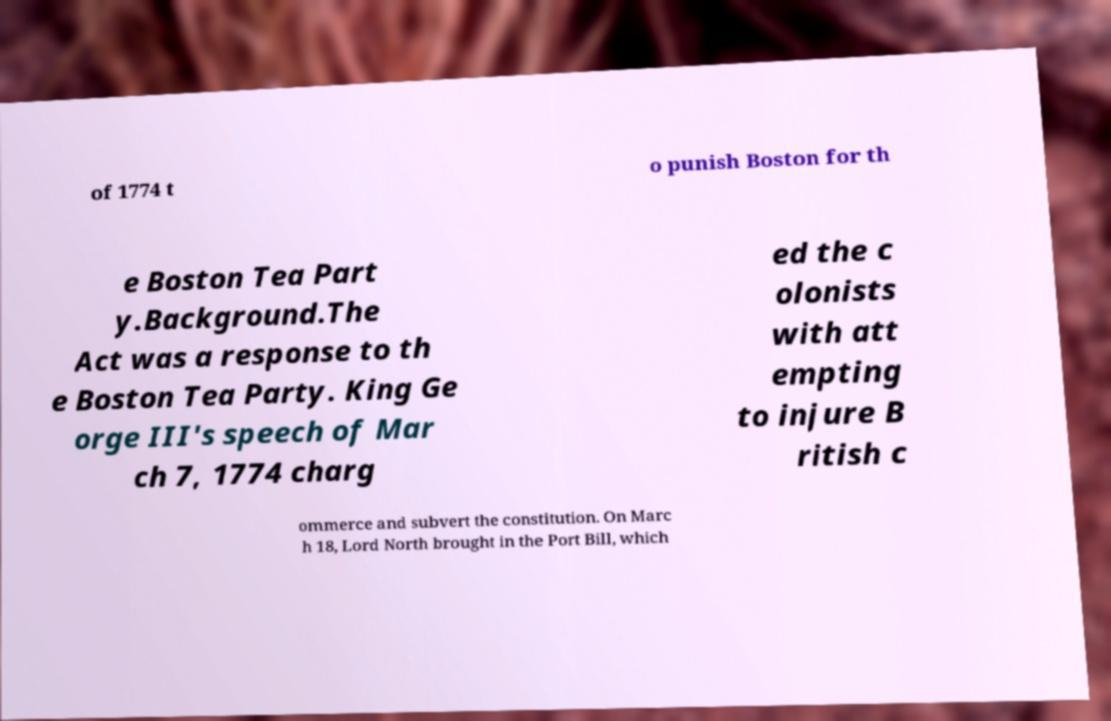Can you accurately transcribe the text from the provided image for me? of 1774 t o punish Boston for th e Boston Tea Part y.Background.The Act was a response to th e Boston Tea Party. King Ge orge III's speech of Mar ch 7, 1774 charg ed the c olonists with att empting to injure B ritish c ommerce and subvert the constitution. On Marc h 18, Lord North brought in the Port Bill, which 